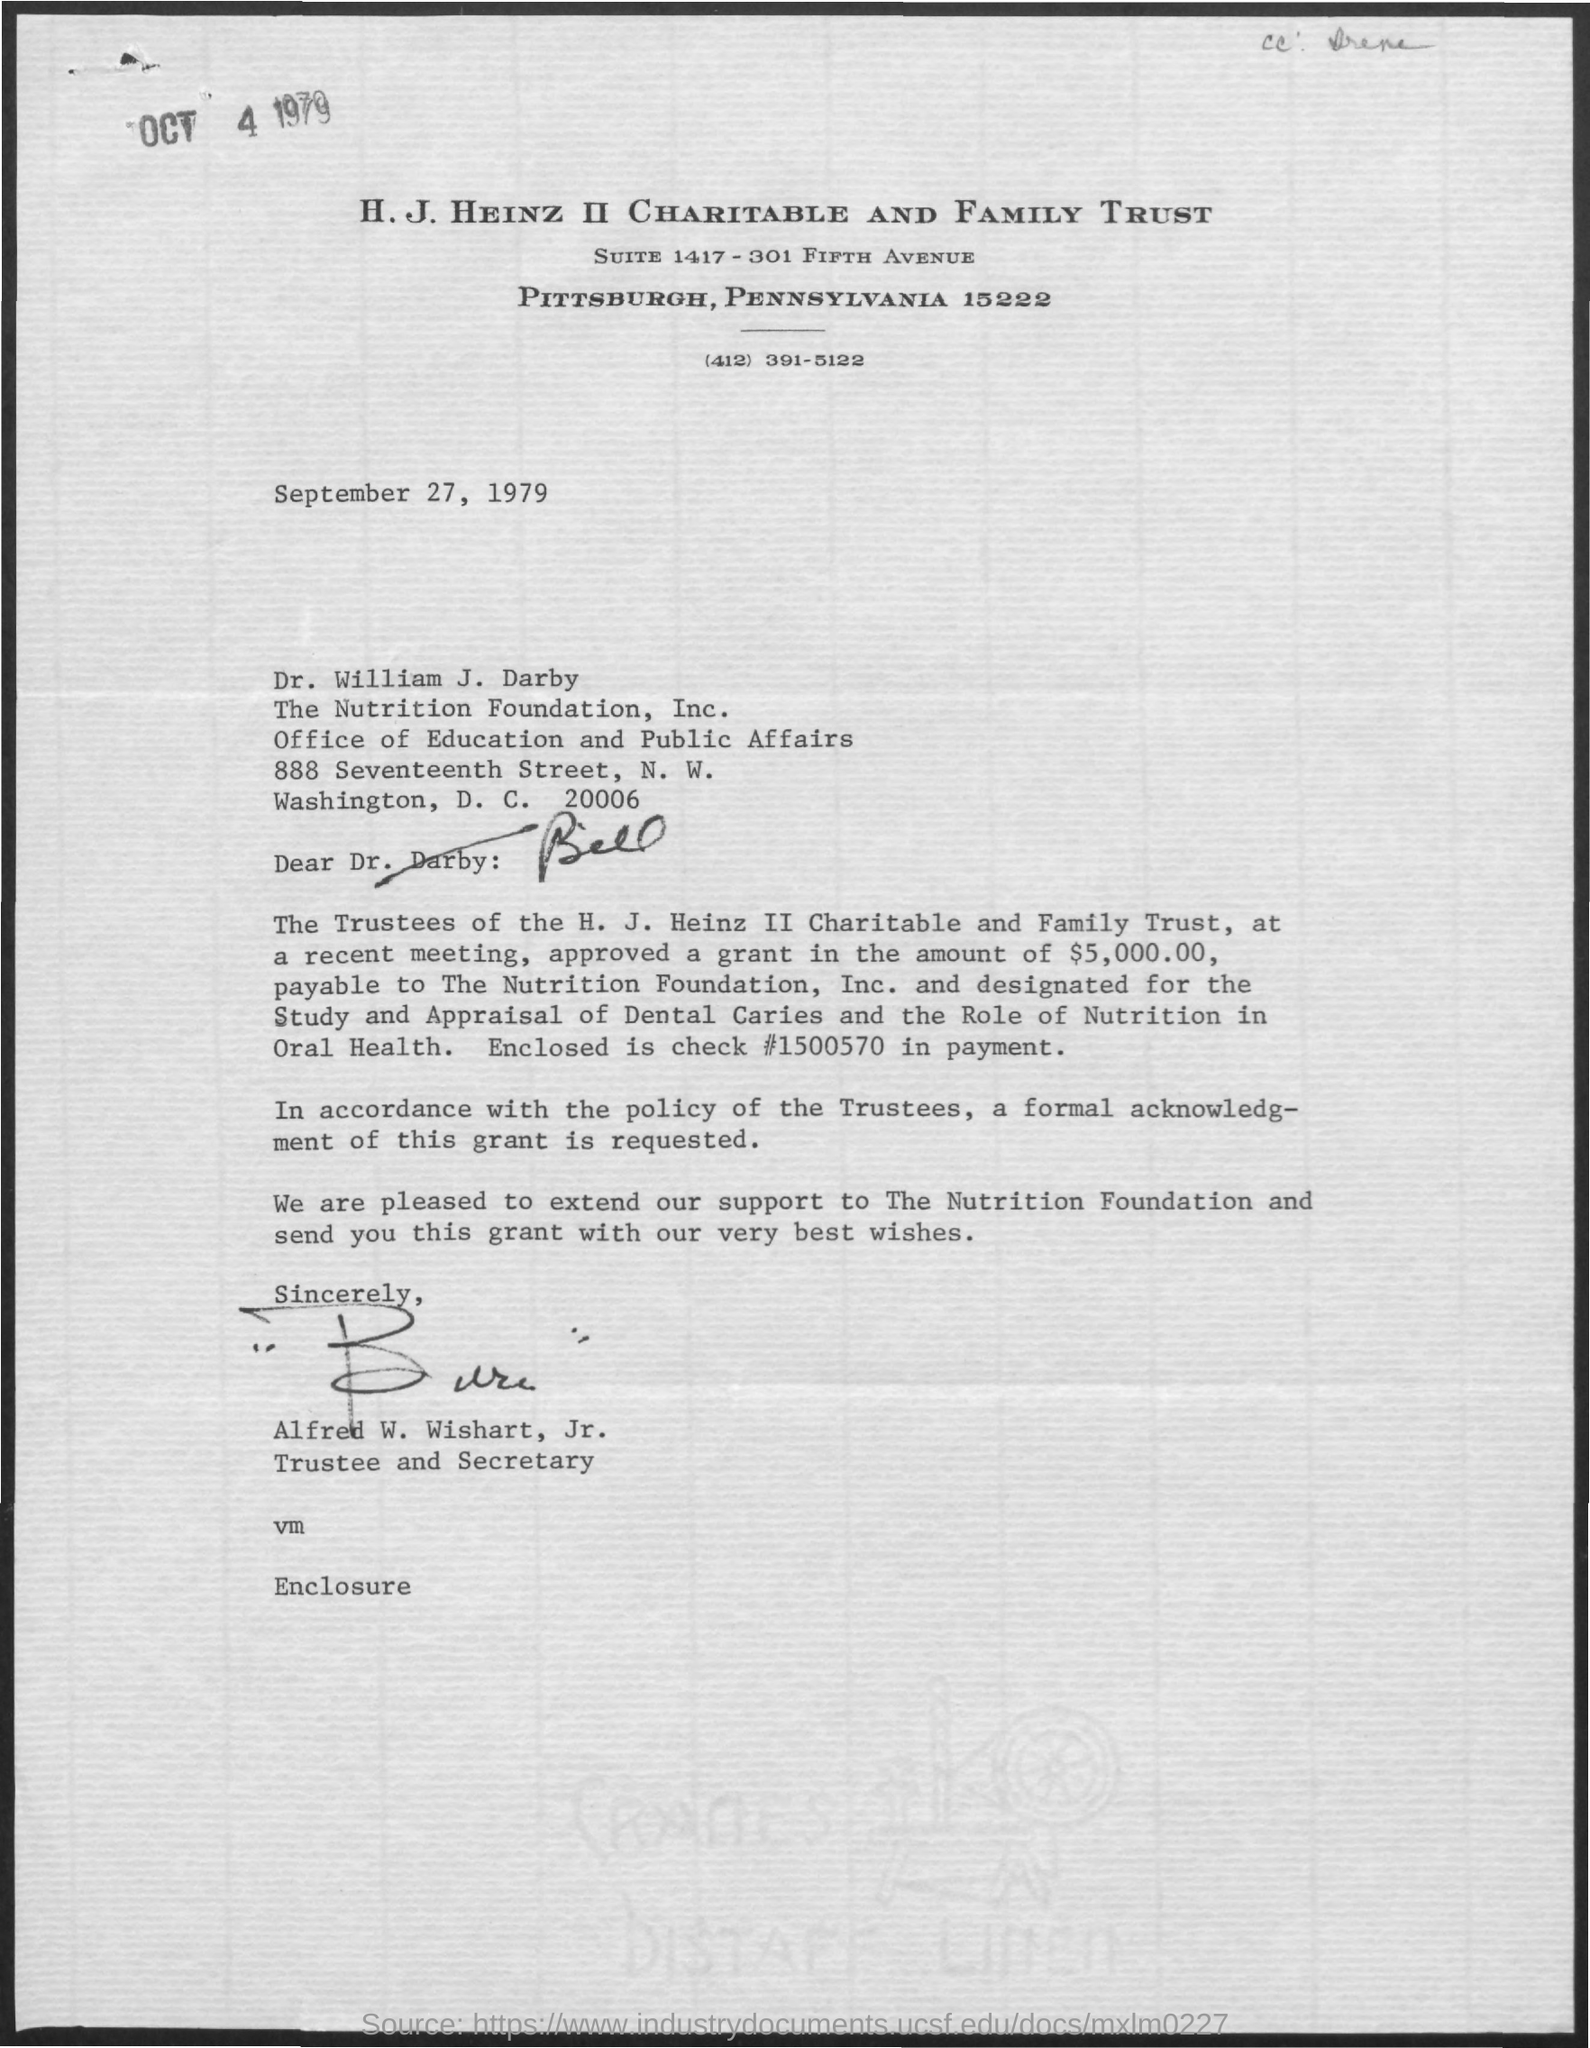Who has signed this letter?
Your response must be concise. Alfred W. Wishart, Jr. What is the designation of Alfred W. Wishart, Jr.?
Keep it short and to the point. Trustee and Secretary. 